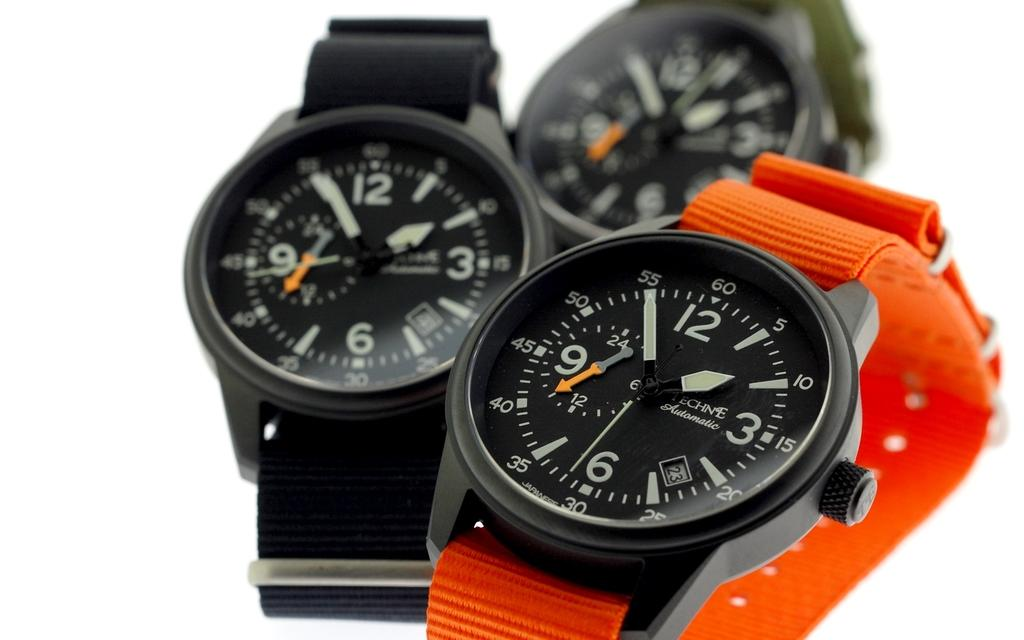<image>
Render a clear and concise summary of the photo. Watches with fabric wristbands, the front one says Techne Automatic on it. 